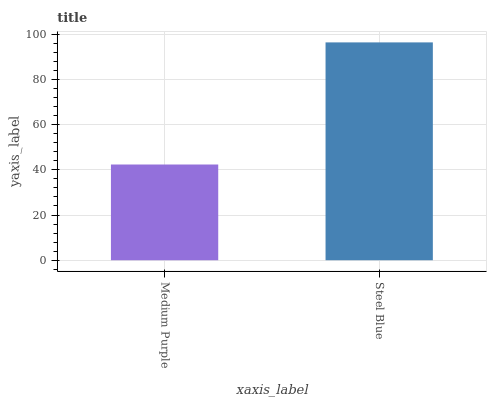Is Steel Blue the minimum?
Answer yes or no. No. Is Steel Blue greater than Medium Purple?
Answer yes or no. Yes. Is Medium Purple less than Steel Blue?
Answer yes or no. Yes. Is Medium Purple greater than Steel Blue?
Answer yes or no. No. Is Steel Blue less than Medium Purple?
Answer yes or no. No. Is Steel Blue the high median?
Answer yes or no. Yes. Is Medium Purple the low median?
Answer yes or no. Yes. Is Medium Purple the high median?
Answer yes or no. No. Is Steel Blue the low median?
Answer yes or no. No. 